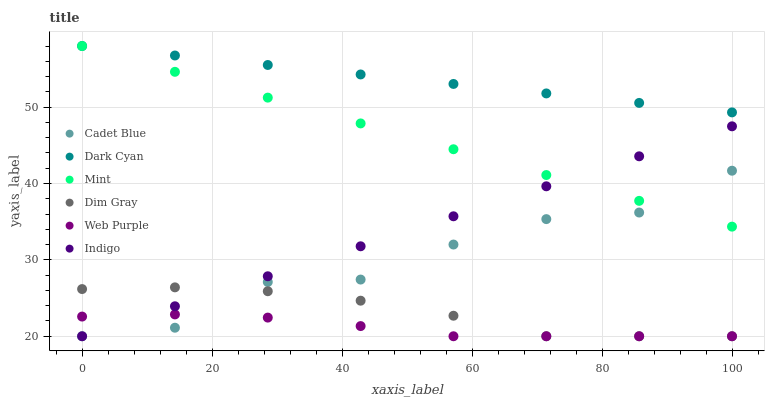Does Web Purple have the minimum area under the curve?
Answer yes or no. Yes. Does Dark Cyan have the maximum area under the curve?
Answer yes or no. Yes. Does Indigo have the minimum area under the curve?
Answer yes or no. No. Does Indigo have the maximum area under the curve?
Answer yes or no. No. Is Indigo the smoothest?
Answer yes or no. Yes. Is Cadet Blue the roughest?
Answer yes or no. Yes. Is Web Purple the smoothest?
Answer yes or no. No. Is Web Purple the roughest?
Answer yes or no. No. Does Dim Gray have the lowest value?
Answer yes or no. Yes. Does Dark Cyan have the lowest value?
Answer yes or no. No. Does Mint have the highest value?
Answer yes or no. Yes. Does Indigo have the highest value?
Answer yes or no. No. Is Dim Gray less than Mint?
Answer yes or no. Yes. Is Dark Cyan greater than Indigo?
Answer yes or no. Yes. Does Indigo intersect Mint?
Answer yes or no. Yes. Is Indigo less than Mint?
Answer yes or no. No. Is Indigo greater than Mint?
Answer yes or no. No. Does Dim Gray intersect Mint?
Answer yes or no. No. 